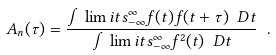<formula> <loc_0><loc_0><loc_500><loc_500>A _ { n } ( \tau ) = \frac { \int \lim i t s ^ { \infty } _ { - \infty } f ( t ) f ( t + \tau ) \ D t } { \int \lim i t s ^ { \infty } _ { - \infty } f ^ { 2 } ( t ) \ D t } \ .</formula> 